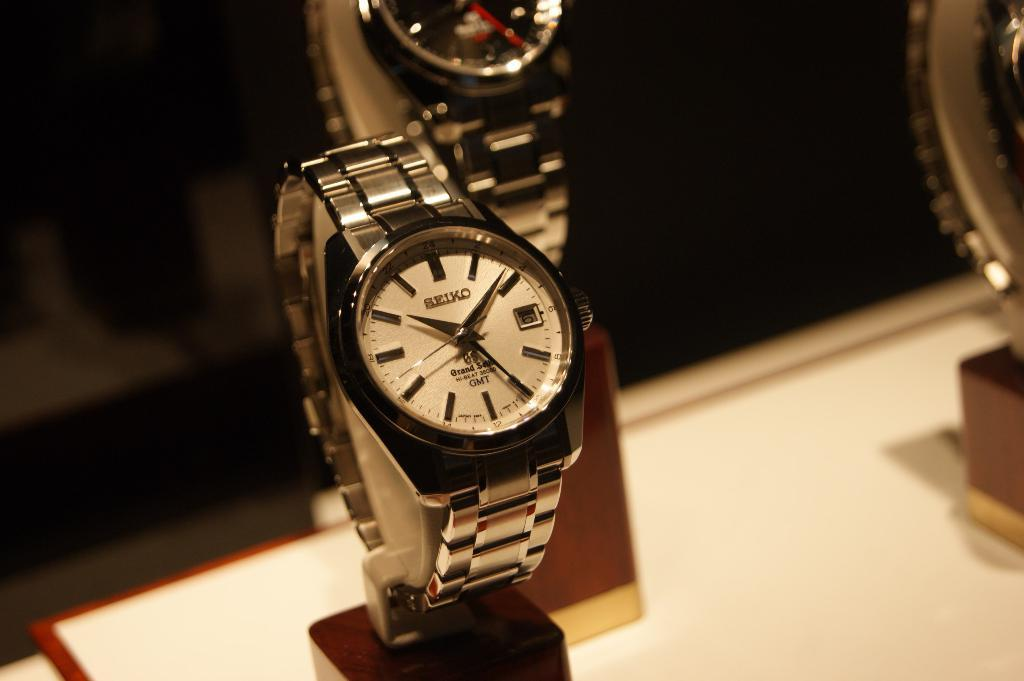<image>
Summarize the visual content of the image. Silver wristwatch which has the word SEIKO on the top. 